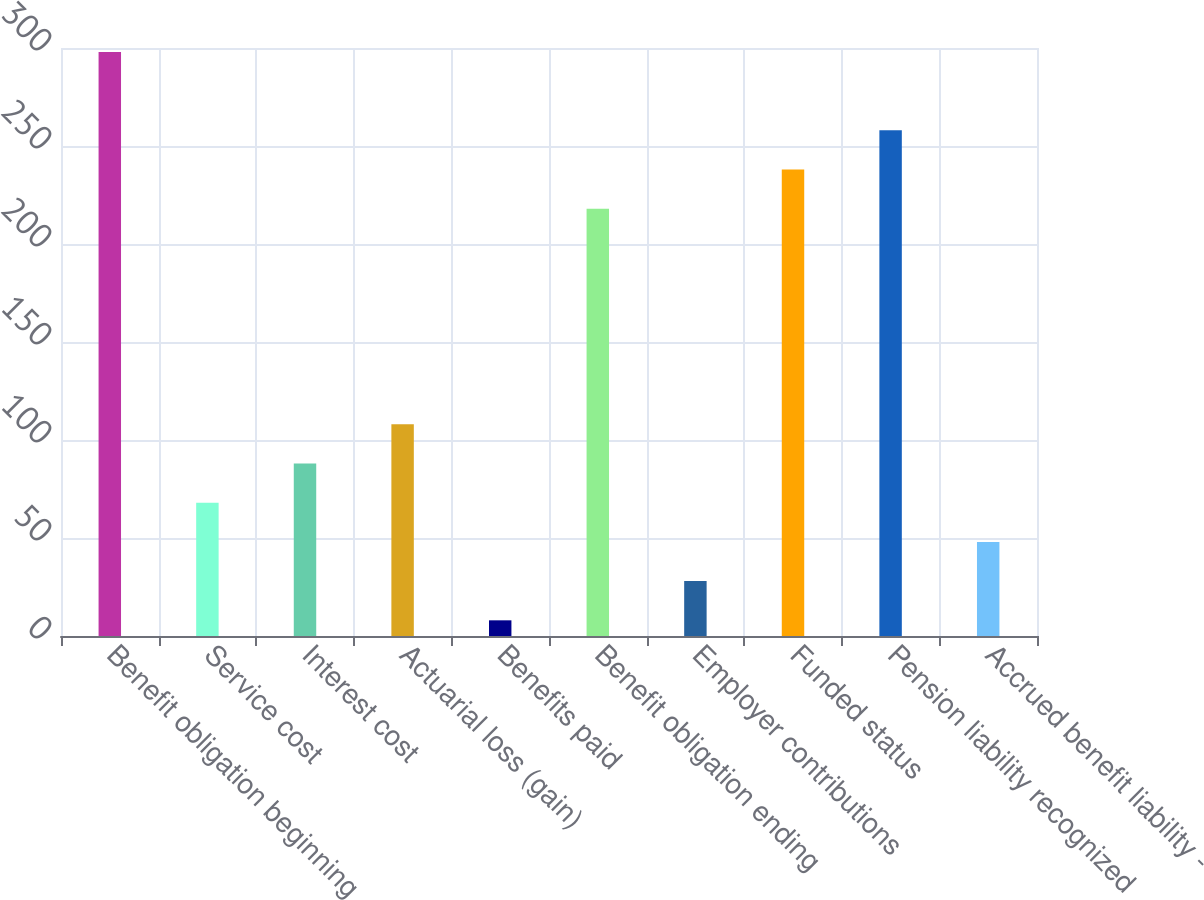Convert chart to OTSL. <chart><loc_0><loc_0><loc_500><loc_500><bar_chart><fcel>Benefit obligation beginning<fcel>Service cost<fcel>Interest cost<fcel>Actuarial loss (gain)<fcel>Benefits paid<fcel>Benefit obligation ending<fcel>Employer contributions<fcel>Funded status<fcel>Pension liability recognized<fcel>Accrued benefit liability -<nl><fcel>298<fcel>68<fcel>88<fcel>108<fcel>8<fcel>218<fcel>28<fcel>238<fcel>258<fcel>48<nl></chart> 